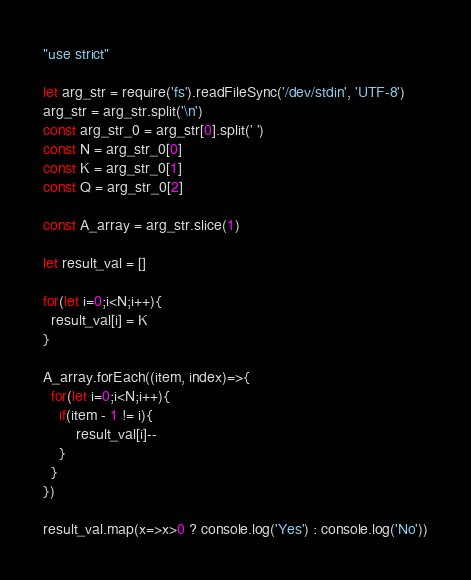Convert code to text. <code><loc_0><loc_0><loc_500><loc_500><_JavaScript_>"use strict"
 
let arg_str = require('fs').readFileSync('/dev/stdin', 'UTF-8')
arg_str = arg_str.split('\n')
const arg_str_0 = arg_str[0].split(' ')
const N = arg_str_0[0]
const K = arg_str_0[1]
const Q = arg_str_0[2]
 
const A_array = arg_str.slice(1)
 
let result_val = []
 
for(let i=0;i<N;i++){
  result_val[i] = K
}
 
A_array.forEach((item, index)=>{
  for(let i=0;i<N;i++){
    if(item - 1 != i){
        result_val[i]--
    }
  }
})
 
result_val.map(x=>x>0 ? console.log('Yes') : console.log('No'))</code> 